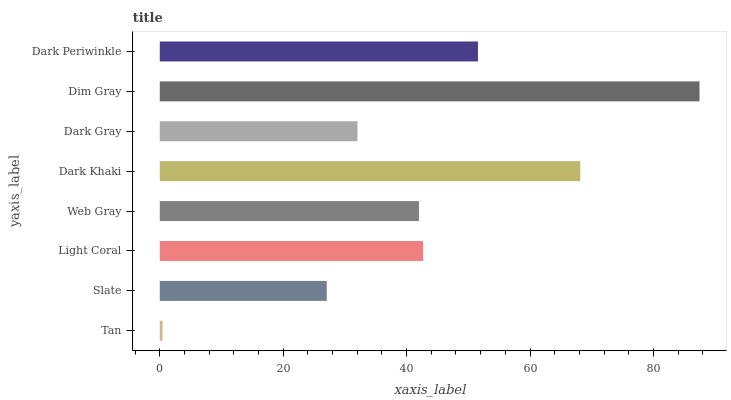Is Tan the minimum?
Answer yes or no. Yes. Is Dim Gray the maximum?
Answer yes or no. Yes. Is Slate the minimum?
Answer yes or no. No. Is Slate the maximum?
Answer yes or no. No. Is Slate greater than Tan?
Answer yes or no. Yes. Is Tan less than Slate?
Answer yes or no. Yes. Is Tan greater than Slate?
Answer yes or no. No. Is Slate less than Tan?
Answer yes or no. No. Is Light Coral the high median?
Answer yes or no. Yes. Is Web Gray the low median?
Answer yes or no. Yes. Is Dim Gray the high median?
Answer yes or no. No. Is Dark Periwinkle the low median?
Answer yes or no. No. 